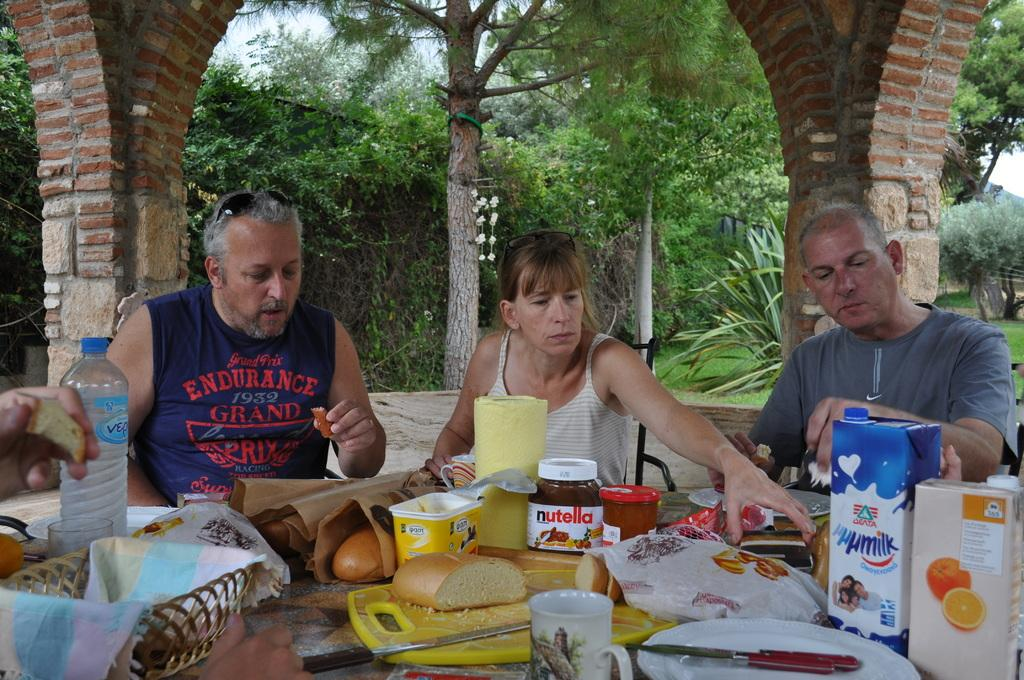How many people are in the image? There are two men and a woman in the image. What is the woman doing in the image? The woman is sitting on a chair in the image. What is on the table in the image? There are food items and a water bottle on the table in the image. What can be seen in the background of the image? There are trees visible in the background of the image. What type of horn can be seen on the donkey in the image? There is no donkey or horn present in the image. 